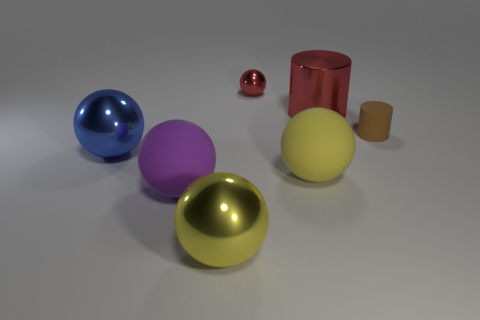Subtract all blue spheres. How many spheres are left? 4 Subtract all big blue spheres. How many spheres are left? 4 Subtract all brown balls. Subtract all green cubes. How many balls are left? 5 Add 2 large gray matte blocks. How many objects exist? 9 Subtract all cylinders. How many objects are left? 5 Add 2 small things. How many small things are left? 4 Add 1 small red things. How many small red things exist? 2 Subtract 0 blue cylinders. How many objects are left? 7 Subtract all tiny rubber cylinders. Subtract all large rubber objects. How many objects are left? 4 